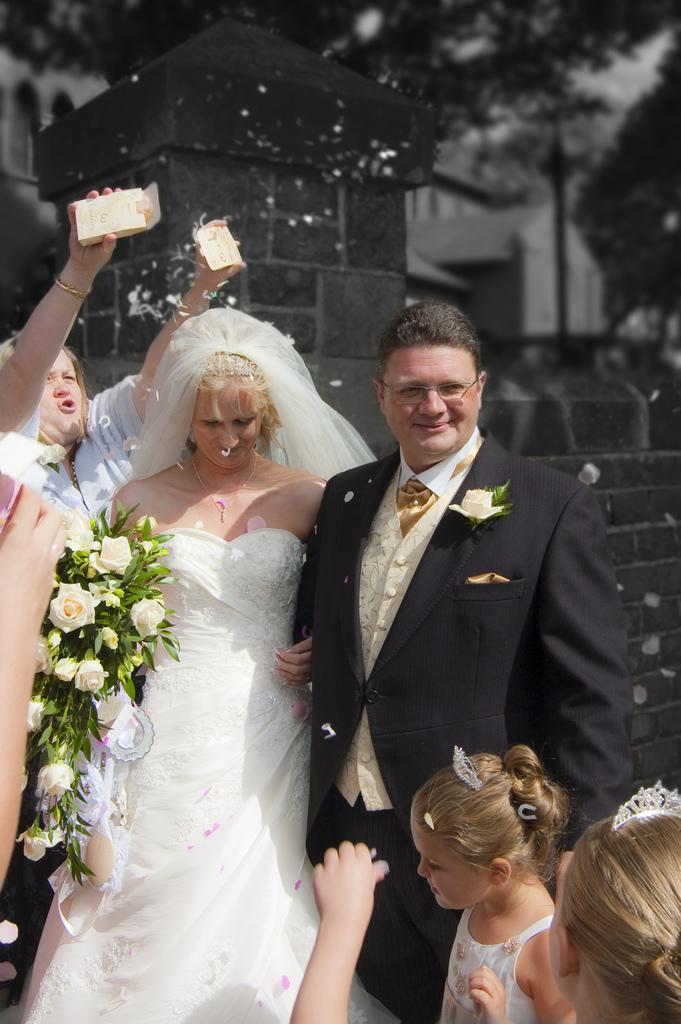Please provide a concise description of this image. In this image we can see a group of people standing on the ground. One woman is wearing a dress is holding some flowers and leaves. On the left side of the image we can see a person holding two boxes in his hands. To the right side of the image we can see two girls wearing a crown. In the background, we can see a wall, tower, building, light pole and a group of trees. 